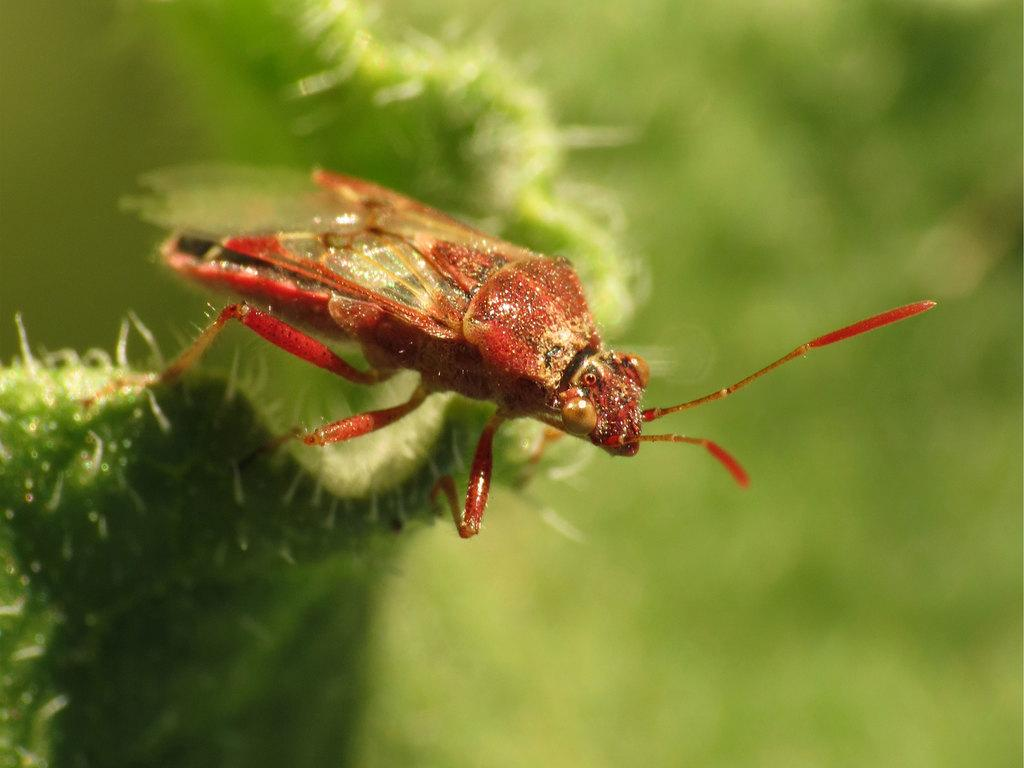What type of creature is in the image? There is an insect in the image. What colors can be seen on the insect? The insect has red and brown colors. Where is the insect located? The insect is on a plant. What can be observed about the background of the image? The background of the image is blurred. What is the purpose of the chicken in the image? There is no chicken present in the image, so it is not possible to determine its purpose. 